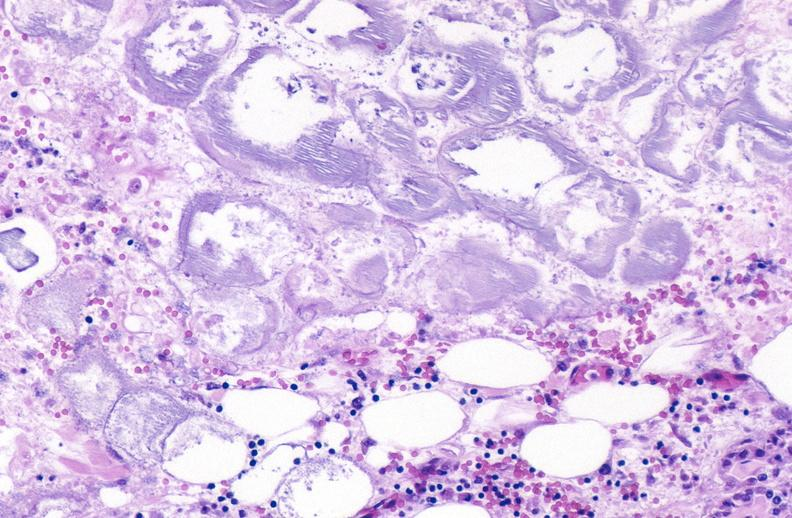does vasculitis due to rocky mountain show pancreatic fat necrosis?
Answer the question using a single word or phrase. No 